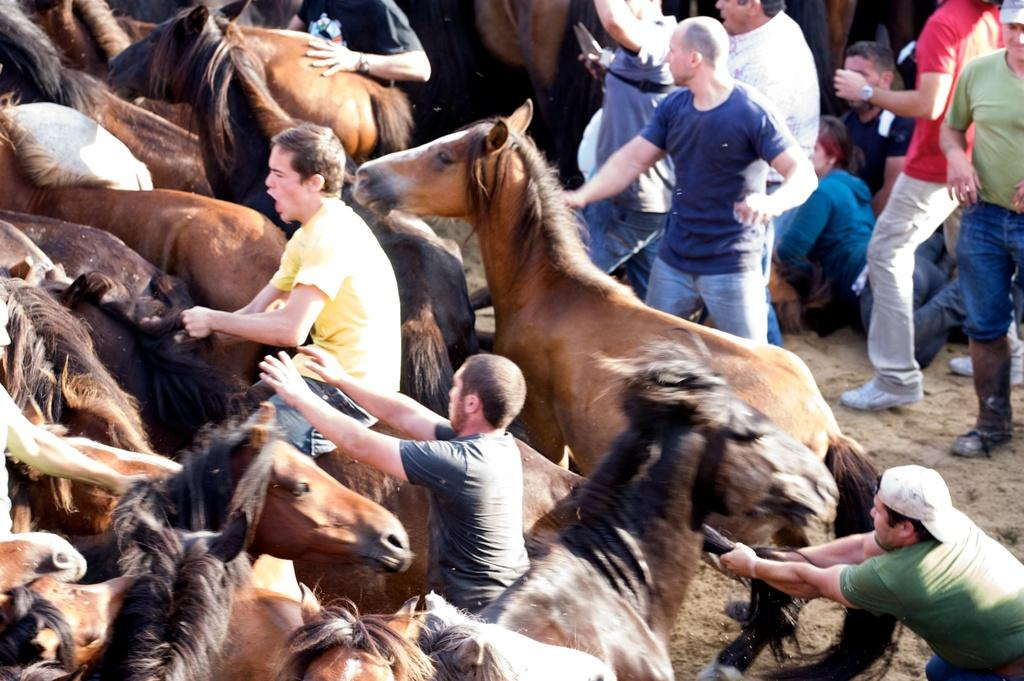What is the main subject of the image? The main subject of the image is a group of people. Are there any animals present in the image? Yes, there are horses in the image. Can you describe the position of the man in the image? A man is seated on a horse on the left side of the image. What type of addition problem can be solved using the horses in the image? There is no addition problem present in the image, as it features a group of people and horses. 